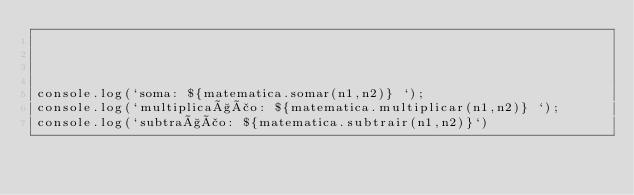Convert code to text. <code><loc_0><loc_0><loc_500><loc_500><_TypeScript_>



console.log(`soma: ${matematica.somar(n1,n2)} `);
console.log(`multiplicação: ${matematica.multiplicar(n1,n2)} `);
console.log(`subtração: ${matematica.subtrair(n1,n2)}`)
</code> 